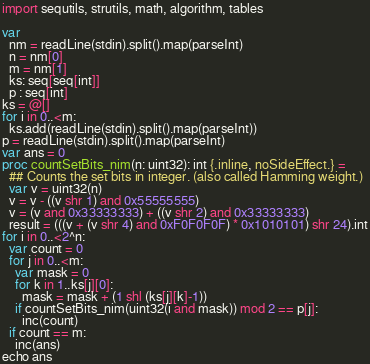<code> <loc_0><loc_0><loc_500><loc_500><_Nim_>import sequtils, strutils, math, algorithm, tables

var
  nm = readLine(stdin).split().map(parseInt)
  n = nm[0]
  m = nm[1]
  ks: seq[seq[int]]
  p : seq[int]
ks = @[]
for i in 0..<m:
  ks.add(readLine(stdin).split().map(parseInt))
p = readLine(stdin).split().map(parseInt)
var ans = 0
proc countSetBits_nim(n: uint32): int {.inline, noSideEffect.} =
  ## Counts the set bits in integer. (also called Hamming weight.)
  var v = uint32(n)
  v = v - ((v shr 1) and 0x55555555)
  v = (v and 0x33333333) + ((v shr 2) and 0x33333333)
  result = (((v + (v shr 4) and 0xF0F0F0F) * 0x1010101) shr 24).int
for i in 0..<2^n:
  var count = 0
  for j in 0..<m:
    var mask = 0
    for k in 1..ks[j][0]:
      mask = mask + (1 shl (ks[j][k]-1))
    if countSetBits_nim(uint32(i and mask)) mod 2 == p[j]:
      inc(count)
  if count == m:
    inc(ans)
echo ans</code> 